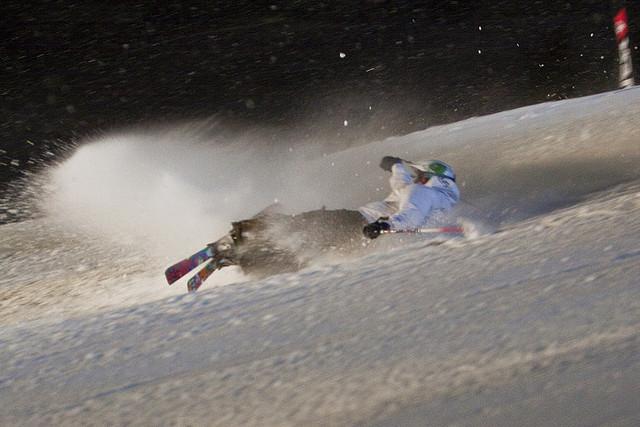Is it day or night?
Write a very short answer. Night. Has the person fallen?
Keep it brief. Yes. Does this look like a sporting event?
Answer briefly. Yes. 